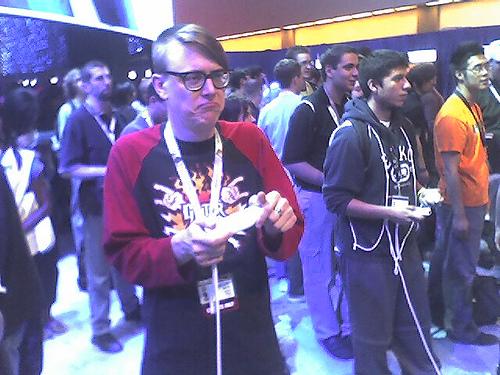What's around his neck?
Keep it brief. Lanyard. Are these all men?
Write a very short answer. Yes. What is this person holding?
Keep it brief. Controller. 